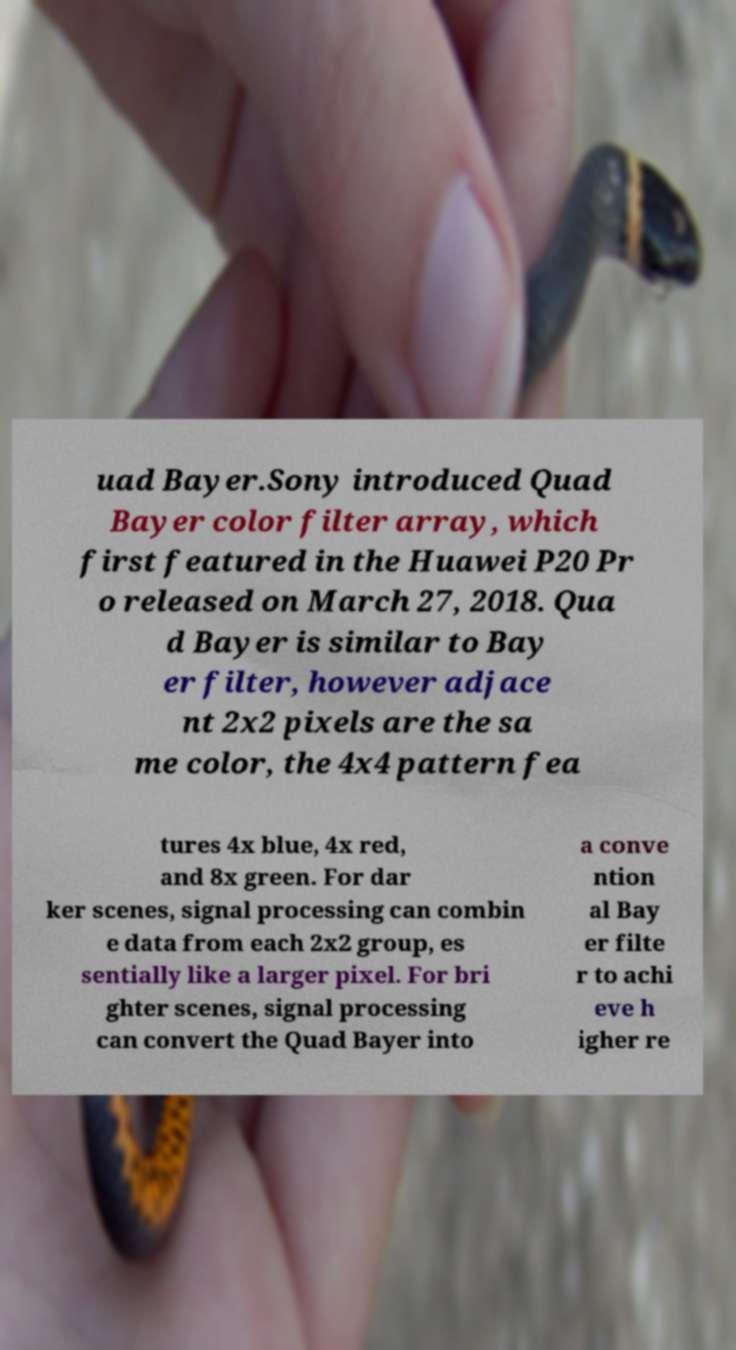I need the written content from this picture converted into text. Can you do that? uad Bayer.Sony introduced Quad Bayer color filter array, which first featured in the Huawei P20 Pr o released on March 27, 2018. Qua d Bayer is similar to Bay er filter, however adjace nt 2x2 pixels are the sa me color, the 4x4 pattern fea tures 4x blue, 4x red, and 8x green. For dar ker scenes, signal processing can combin e data from each 2x2 group, es sentially like a larger pixel. For bri ghter scenes, signal processing can convert the Quad Bayer into a conve ntion al Bay er filte r to achi eve h igher re 